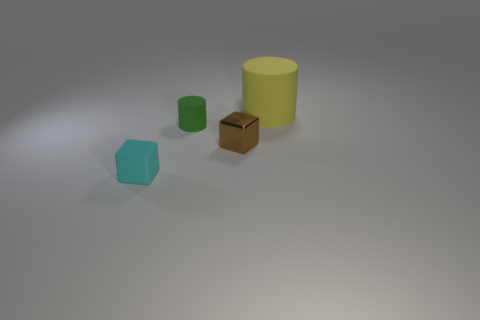Add 1 green metal cylinders. How many objects exist? 5 Subtract all brown cubes. How many cubes are left? 1 Subtract all gray spheres. How many purple cylinders are left? 0 Add 2 yellow rubber objects. How many yellow rubber objects are left? 3 Add 3 small objects. How many small objects exist? 6 Subtract 0 red cubes. How many objects are left? 4 Subtract 1 cylinders. How many cylinders are left? 1 Subtract all red cubes. Subtract all brown balls. How many cubes are left? 2 Subtract all rubber blocks. Subtract all tiny cyan blocks. How many objects are left? 2 